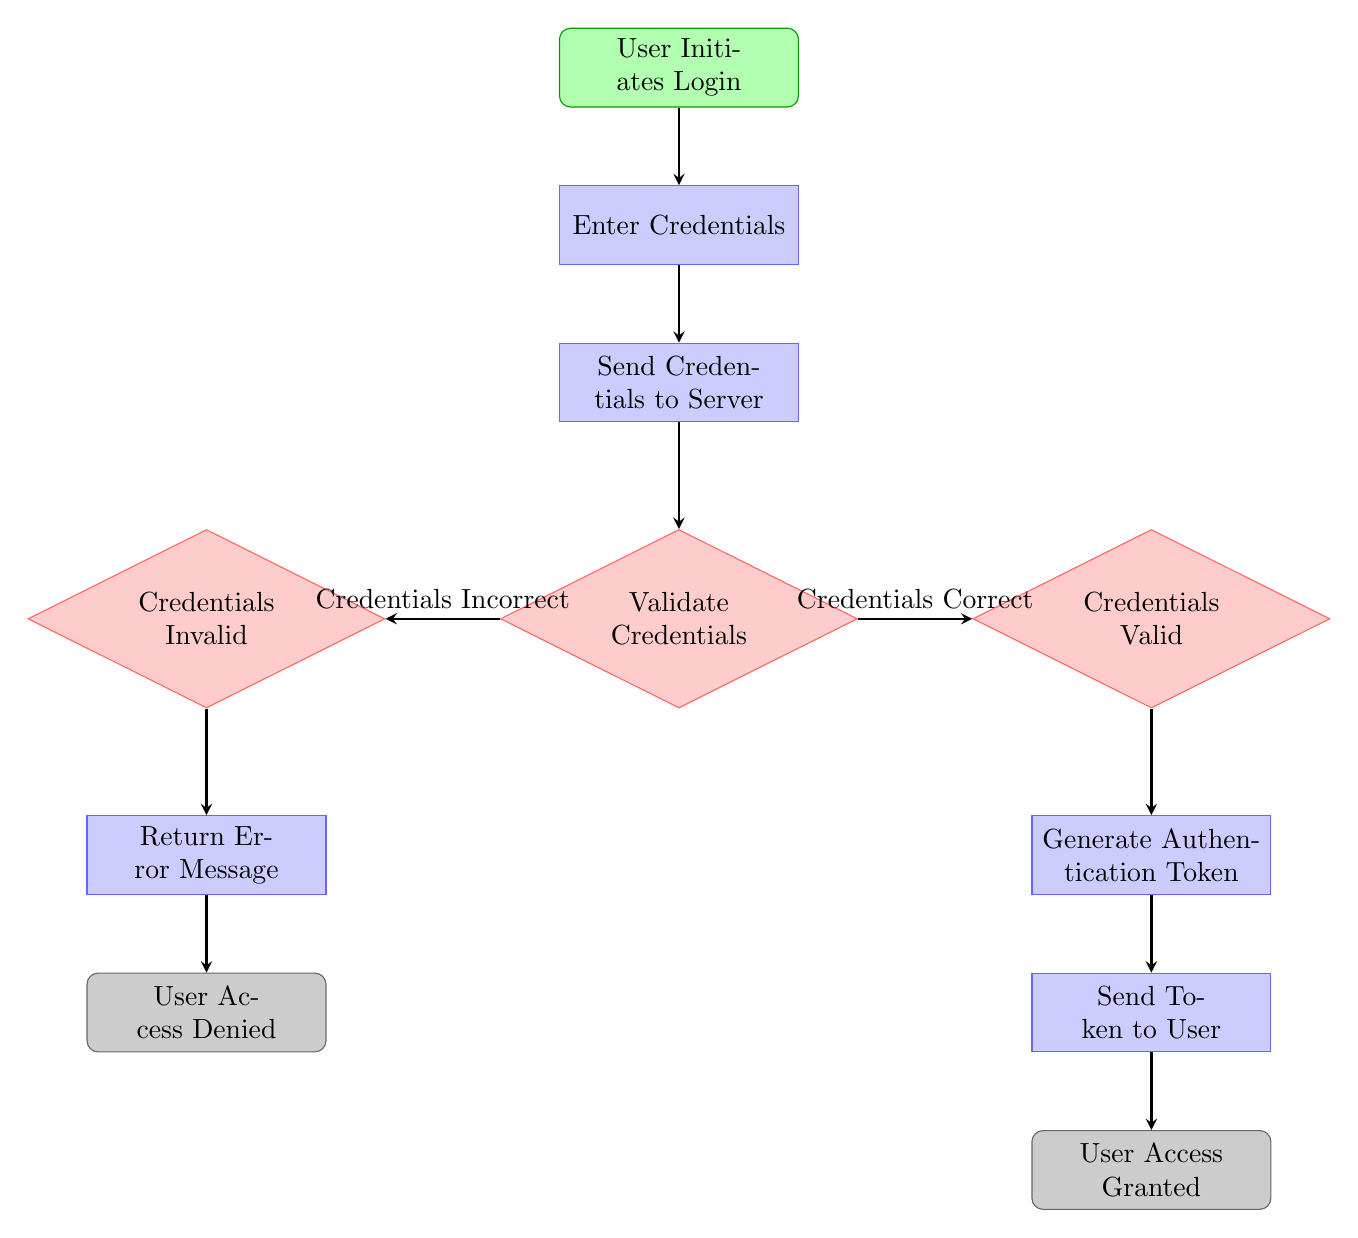What is the first action in the user authentication flow? The first action in the diagram is labeled as "User Initiates Login," which signifies the beginning of the authentication process for the user.
Answer: User Initiates Login How many decision nodes are in the diagram? The diagram contains two decision nodes: "Validate Credentials" and "Credentials Valid." These nodes determine the flow based on the correctness of the credentials provided.
Answer: 2 What happens after credentials are validated as valid? After the credentials are validated as valid, the flow continues to the process labeled "Generate Authentication Token," indicating the next step in the authentication flow.
Answer: Generate Authentication Token What is the final endpoint in the authentication process? The final endpoint in the diagram is "User Access Granted," which represents the successful completion of the authentication process where the user gains access.
Answer: User Access Granted What action follows an invalid credential check? Following an invalid credential check, the next action is "Return Error Message," which indicates that the system informs the user about the incorrect credentials entered.
Answer: Return Error Message If credentials are invalid, what is the end state? If the credentials are found to be invalid, the end state is "User Access Denied," which signifies that the user cannot access the system due to incorrect credentials.
Answer: User Access Denied Which node does the process of sending credentials to the server follow? The process of sending credentials to the server follows the "Enter Credentials" node, which is where the user inputs their login details before they are transmitted.
Answer: Send Credentials to Server What is the relationship between "Validate Credentials" and "Credentials Valid"? The relationship is that "Validate Credentials" is a decision point that flows to either "Credentials Valid" if the credentials are correct or "Credentials Invalid" if they are not, based on the validation check.
Answer: Decision Point 